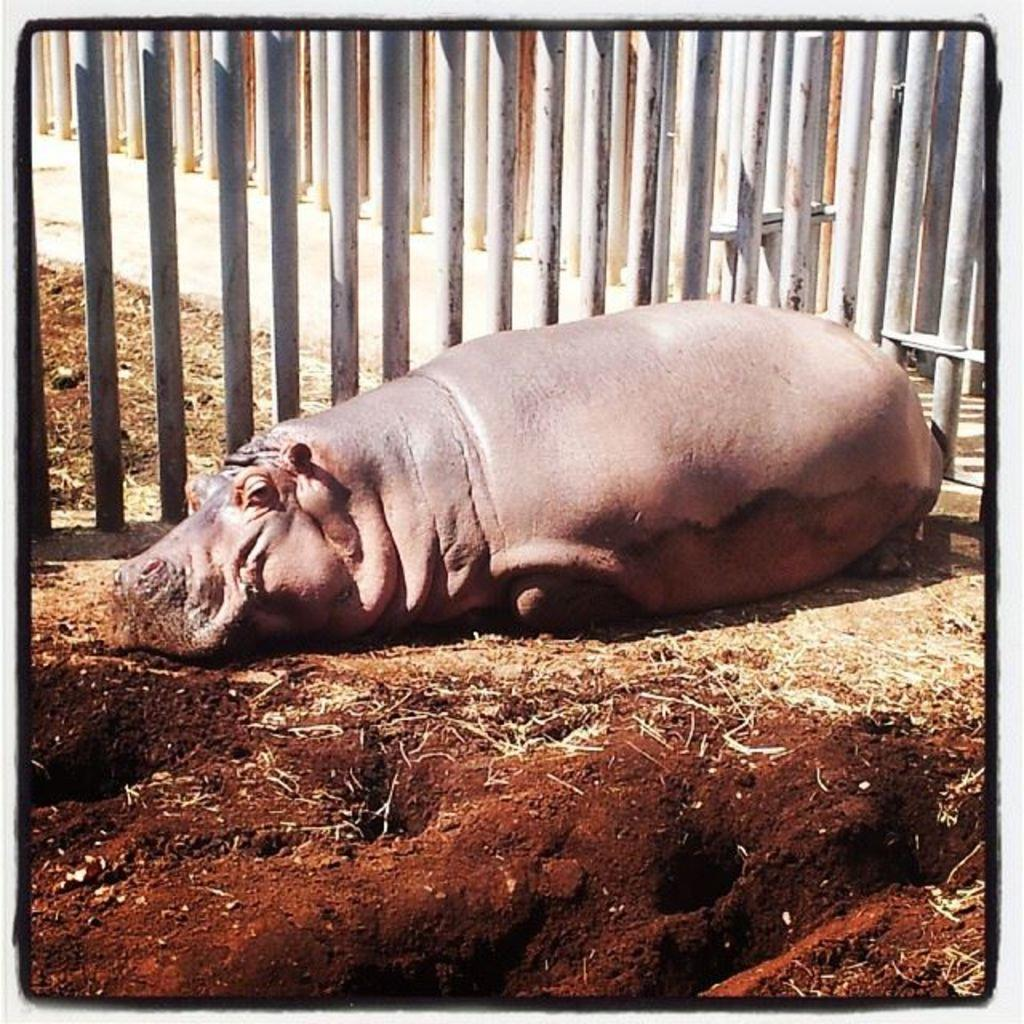What animal is the main subject of the image? There is a hippopotamus in the image. What is the hippopotamus doing in the image? The hippopotamus is resting on the ground. What can be seen in the background of the image? There is fencing behind the hippopotamus. What nation is the hippopotamus representing in the image? The image does not depict the hippopotamus representing any nation. Can you see a pin on the hippopotamus in the image? There is no pin visible on the hippopotamus in the image. 